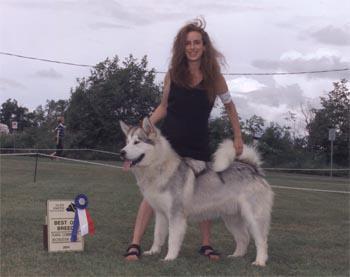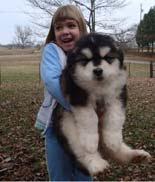The first image is the image on the left, the second image is the image on the right. Analyze the images presented: Is the assertion "The left and right image contains the same number of dogs." valid? Answer yes or no. Yes. The first image is the image on the left, the second image is the image on the right. Evaluate the accuracy of this statement regarding the images: "One image shows a woman standing behind a dog standing in profile turned leftward, and a sign with a prize ribbon is upright on the ground in front of the dog.". Is it true? Answer yes or no. Yes. 